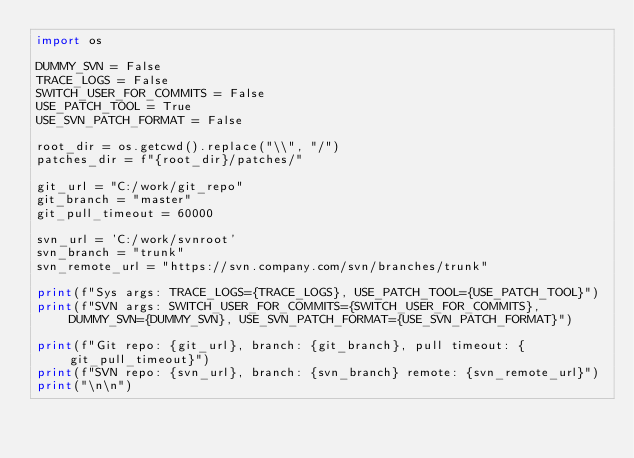Convert code to text. <code><loc_0><loc_0><loc_500><loc_500><_Python_>import os

DUMMY_SVN = False
TRACE_LOGS = False
SWITCH_USER_FOR_COMMITS = False
USE_PATCH_TOOL = True
USE_SVN_PATCH_FORMAT = False

root_dir = os.getcwd().replace("\\", "/")
patches_dir = f"{root_dir}/patches/"

git_url = "C:/work/git_repo"
git_branch = "master"
git_pull_timeout = 60000

svn_url = 'C:/work/svnroot'
svn_branch = "trunk"
svn_remote_url = "https://svn.company.com/svn/branches/trunk"

print(f"Sys args: TRACE_LOGS={TRACE_LOGS}, USE_PATCH_TOOL={USE_PATCH_TOOL}")
print(f"SVN args: SWITCH_USER_FOR_COMMITS={SWITCH_USER_FOR_COMMITS}, DUMMY_SVN={DUMMY_SVN}, USE_SVN_PATCH_FORMAT={USE_SVN_PATCH_FORMAT}")

print(f"Git repo: {git_url}, branch: {git_branch}, pull timeout: {git_pull_timeout}")
print(f"SVN repo: {svn_url}, branch: {svn_branch} remote: {svn_remote_url}")
print("\n\n")
</code> 